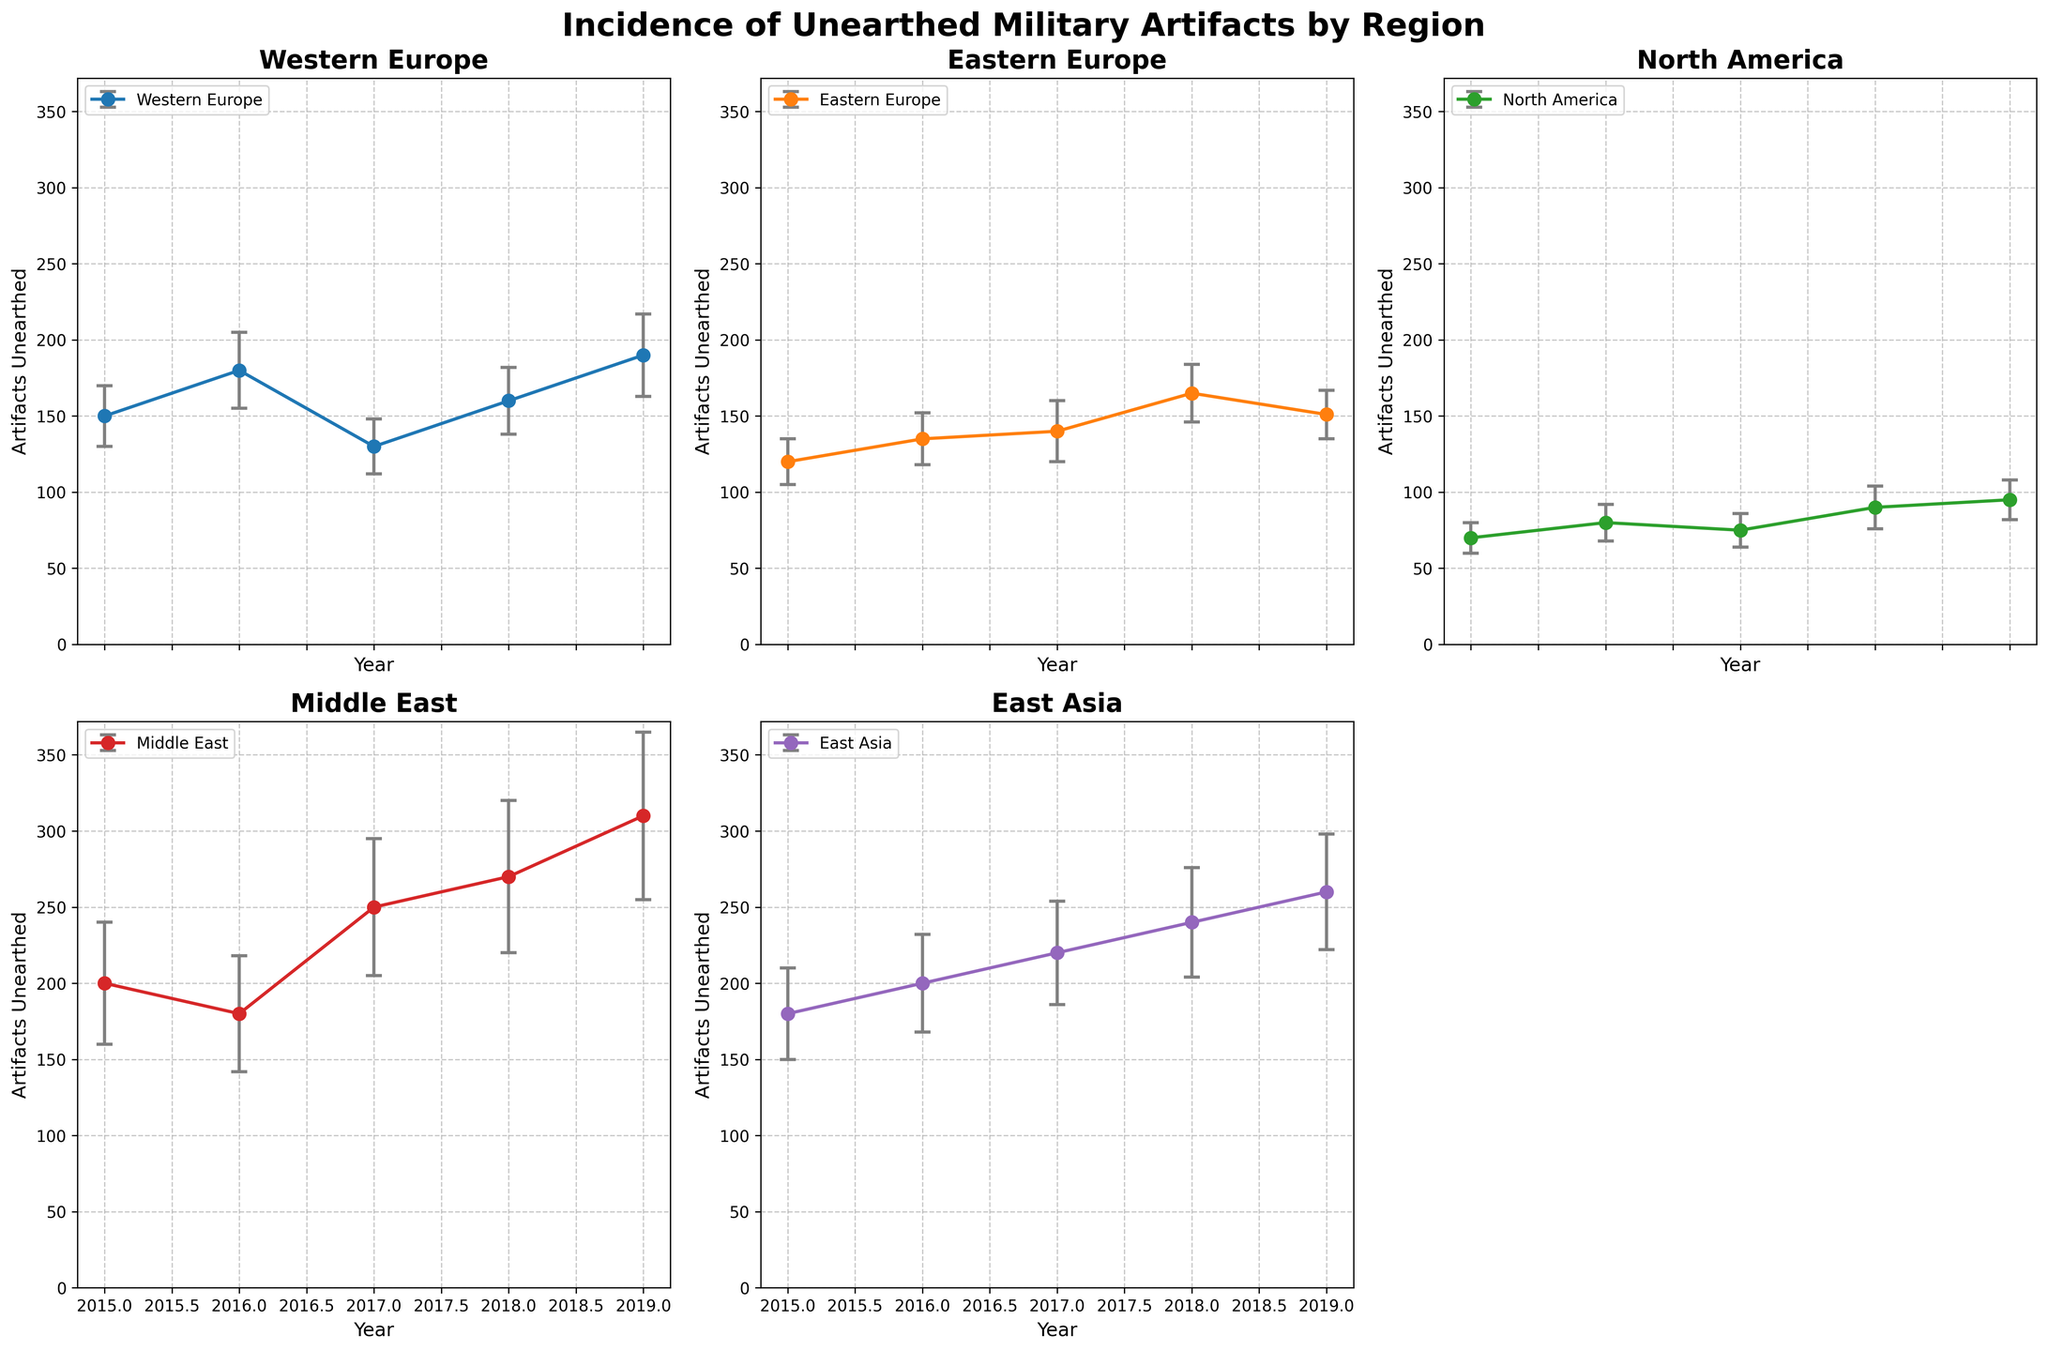How many regions have their own subplot? There are five regions presented in the figure as subplots. Each region is given a separate subplot to display its data over the years. One subplot is left empty as there are only five regions but six positions available in the (2, 3) grid.
Answer: 5 Which region has the highest number of artifacts unearthed in any given year? In the subplot for the Middle East, the highest number of artifacts unearthed in a single year is 310 in 2019. This is the highest value across all regions and years displayed in the figure.
Answer: Middle East What is the title of the figure? The title of the figure is clearly stated at the top as "Incidence of Unearthed Military Artifacts by Region."
Answer: Incidence of Unearthed Military Artifacts by Region Which region shows the most consistent number of artifacts unearthed based on the error bars? Eastern Europe shows the least variability in the number of artifacts unearthed over the years, indicated by relatively smaller error bars compared to other regions.
Answer: Eastern Europe Between 2015 and 2016, which region shows the largest increase in artifacts unearthed? The subplot for the Middle East shows the artifacts unearthed increased from 200 in 2015 to 180 in 2016, an increase of 80 artifacts. This increase is the largest compared to other regions.
Answer: Middle East Which region displays the largest variability in historical records (standard deviation) in recent years? The Middle East region shows the largest variability with an error bar reaching up to 55 in 2019, indicating significant historical record variability.
Answer: Middle East During which year does Eastern Europe see the highest number of artifacts unearthed? In Eastern Europe, the highest number of artifacts unearthed occurs in 2018, with a value of 165 artifacts.
Answer: 2018 By how much has the number of artifacts unearthed in North America increased from 2015 to 2019? From 2015 to 2019 in North America, the number of artifacts unearthed increased from 70 to 95. The difference is 95 - 70 = 25 artifacts.
Answer: 25 Which regions have a higher number of artifacts unearthed in 2019 compared to Eastern Europe? In 2019, Western Europe, North America, and the Middle East all have a higher number of artifacts unearthed compared to Eastern Europe, which has 151 artifacts unearthed. Middle East has 310, East Asia has 260, Western Europe has 190, and North America has 95 artifacts unearthed. Thus, Middle East, East Asia, and Western Europe are higher than Eastern Europe.
Answer: Western Europe, Middle East, East Asia 